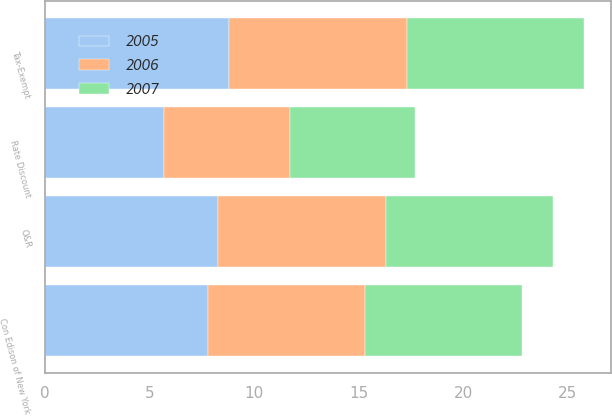Convert chart to OTSL. <chart><loc_0><loc_0><loc_500><loc_500><stacked_bar_chart><ecel><fcel>Rate Discount<fcel>Tax-Exempt<fcel>Con Edison of New York<fcel>O&R<nl><fcel>2007<fcel>6<fcel>8.5<fcel>7.5<fcel>8<nl><fcel>2006<fcel>6<fcel>8.5<fcel>7.5<fcel>8<nl><fcel>2005<fcel>5.7<fcel>8.8<fcel>7.8<fcel>8.3<nl></chart> 